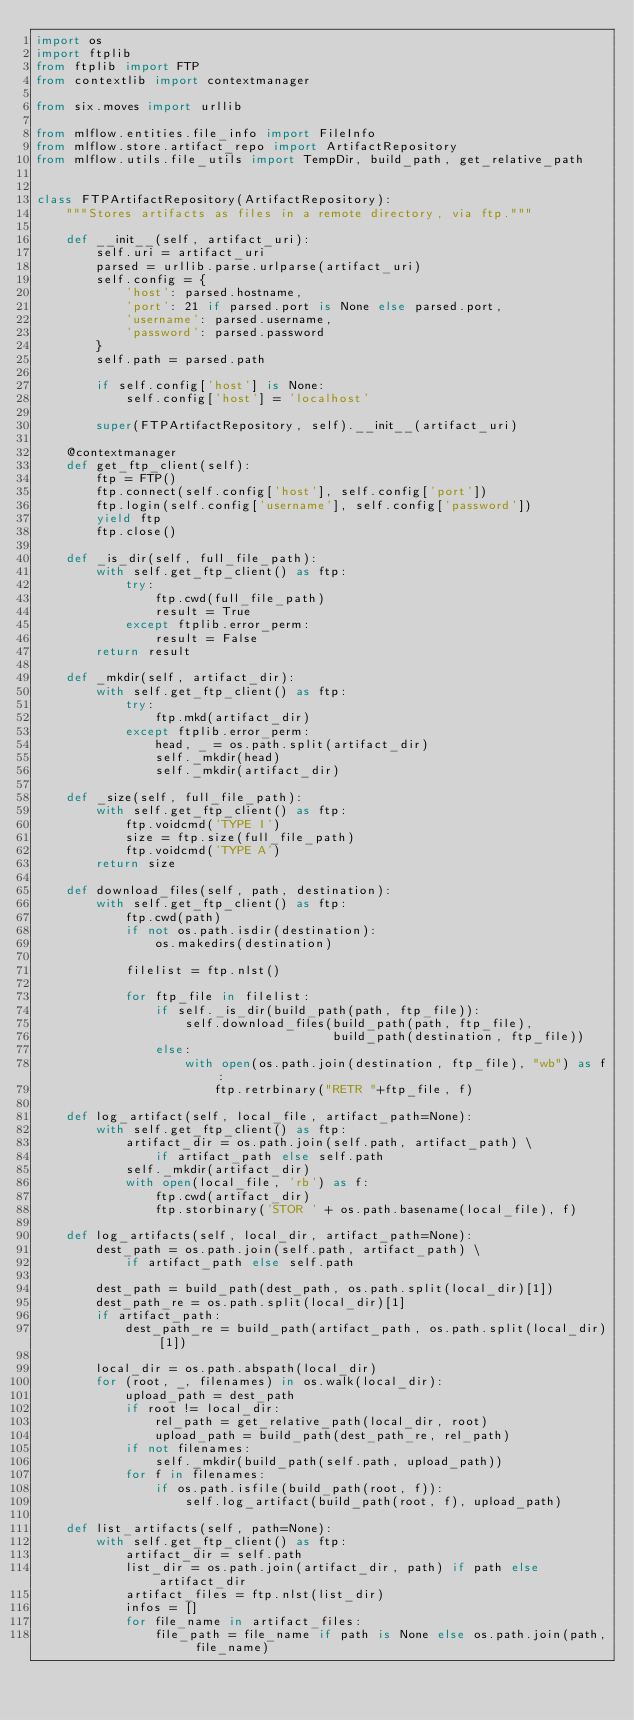<code> <loc_0><loc_0><loc_500><loc_500><_Python_>import os
import ftplib
from ftplib import FTP
from contextlib import contextmanager

from six.moves import urllib

from mlflow.entities.file_info import FileInfo
from mlflow.store.artifact_repo import ArtifactRepository
from mlflow.utils.file_utils import TempDir, build_path, get_relative_path


class FTPArtifactRepository(ArtifactRepository):
    """Stores artifacts as files in a remote directory, via ftp."""

    def __init__(self, artifact_uri):
        self.uri = artifact_uri
        parsed = urllib.parse.urlparse(artifact_uri)
        self.config = {
            'host': parsed.hostname,
            'port': 21 if parsed.port is None else parsed.port,
            'username': parsed.username,
            'password': parsed.password
        }
        self.path = parsed.path

        if self.config['host'] is None:
            self.config['host'] = 'localhost'

        super(FTPArtifactRepository, self).__init__(artifact_uri)

    @contextmanager
    def get_ftp_client(self):
        ftp = FTP()
        ftp.connect(self.config['host'], self.config['port'])
        ftp.login(self.config['username'], self.config['password'])
        yield ftp
        ftp.close()

    def _is_dir(self, full_file_path):
        with self.get_ftp_client() as ftp:
            try:
                ftp.cwd(full_file_path)
                result = True
            except ftplib.error_perm:
                result = False
        return result

    def _mkdir(self, artifact_dir):
        with self.get_ftp_client() as ftp:
            try:
                ftp.mkd(artifact_dir)
            except ftplib.error_perm:
                head, _ = os.path.split(artifact_dir)
                self._mkdir(head)
                self._mkdir(artifact_dir)

    def _size(self, full_file_path):
        with self.get_ftp_client() as ftp:
            ftp.voidcmd('TYPE I')
            size = ftp.size(full_file_path)
            ftp.voidcmd('TYPE A')
        return size

    def download_files(self, path, destination):
        with self.get_ftp_client() as ftp:
            ftp.cwd(path)
            if not os.path.isdir(destination):
                os.makedirs(destination)

            filelist = ftp.nlst()

            for ftp_file in filelist:
                if self._is_dir(build_path(path, ftp_file)):
                    self.download_files(build_path(path, ftp_file),
                                        build_path(destination, ftp_file))
                else:
                    with open(os.path.join(destination, ftp_file), "wb") as f:
                        ftp.retrbinary("RETR "+ftp_file, f)

    def log_artifact(self, local_file, artifact_path=None):
        with self.get_ftp_client() as ftp:
            artifact_dir = os.path.join(self.path, artifact_path) \
                if artifact_path else self.path
            self._mkdir(artifact_dir)
            with open(local_file, 'rb') as f:
                ftp.cwd(artifact_dir)
                ftp.storbinary('STOR ' + os.path.basename(local_file), f)

    def log_artifacts(self, local_dir, artifact_path=None):
        dest_path = os.path.join(self.path, artifact_path) \
            if artifact_path else self.path

        dest_path = build_path(dest_path, os.path.split(local_dir)[1])
        dest_path_re = os.path.split(local_dir)[1]
        if artifact_path:
            dest_path_re = build_path(artifact_path, os.path.split(local_dir)[1])

        local_dir = os.path.abspath(local_dir)
        for (root, _, filenames) in os.walk(local_dir):
            upload_path = dest_path
            if root != local_dir:
                rel_path = get_relative_path(local_dir, root)
                upload_path = build_path(dest_path_re, rel_path)
            if not filenames:
                self._mkdir(build_path(self.path, upload_path))
            for f in filenames:
                if os.path.isfile(build_path(root, f)):
                    self.log_artifact(build_path(root, f), upload_path)

    def list_artifacts(self, path=None):
        with self.get_ftp_client() as ftp:
            artifact_dir = self.path
            list_dir = os.path.join(artifact_dir, path) if path else artifact_dir
            artifact_files = ftp.nlst(list_dir)
            infos = []
            for file_name in artifact_files:
                file_path = file_name if path is None else os.path.join(path, file_name)</code> 